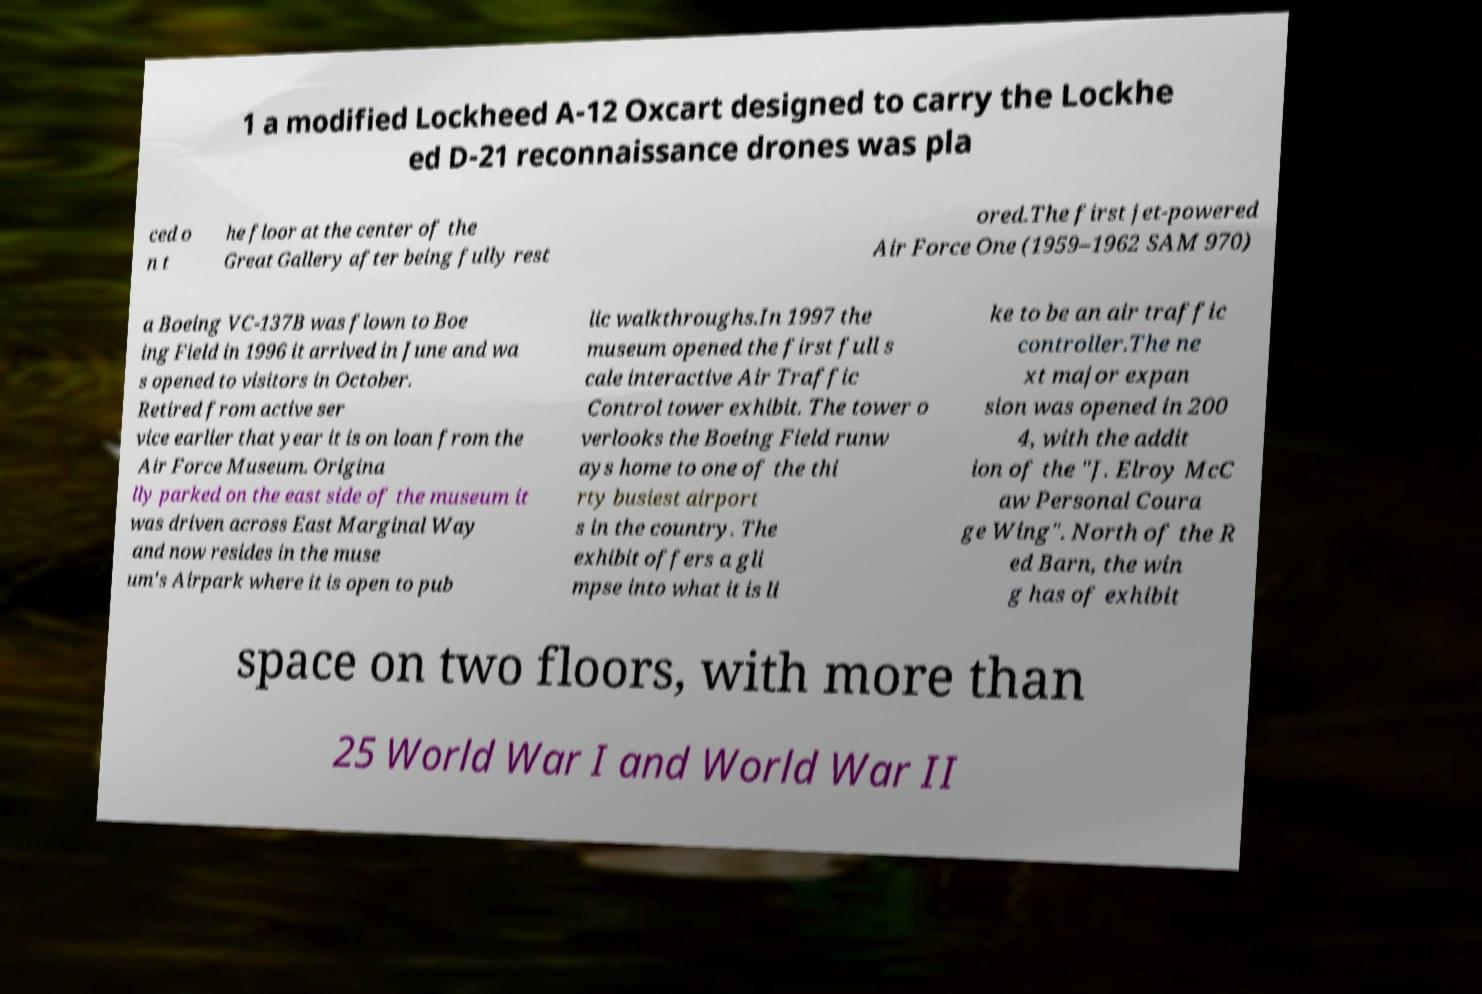Can you accurately transcribe the text from the provided image for me? 1 a modified Lockheed A-12 Oxcart designed to carry the Lockhe ed D-21 reconnaissance drones was pla ced o n t he floor at the center of the Great Gallery after being fully rest ored.The first jet-powered Air Force One (1959–1962 SAM 970) a Boeing VC-137B was flown to Boe ing Field in 1996 it arrived in June and wa s opened to visitors in October. Retired from active ser vice earlier that year it is on loan from the Air Force Museum. Origina lly parked on the east side of the museum it was driven across East Marginal Way and now resides in the muse um's Airpark where it is open to pub lic walkthroughs.In 1997 the museum opened the first full s cale interactive Air Traffic Control tower exhibit. The tower o verlooks the Boeing Field runw ays home to one of the thi rty busiest airport s in the country. The exhibit offers a gli mpse into what it is li ke to be an air traffic controller.The ne xt major expan sion was opened in 200 4, with the addit ion of the "J. Elroy McC aw Personal Coura ge Wing". North of the R ed Barn, the win g has of exhibit space on two floors, with more than 25 World War I and World War II 